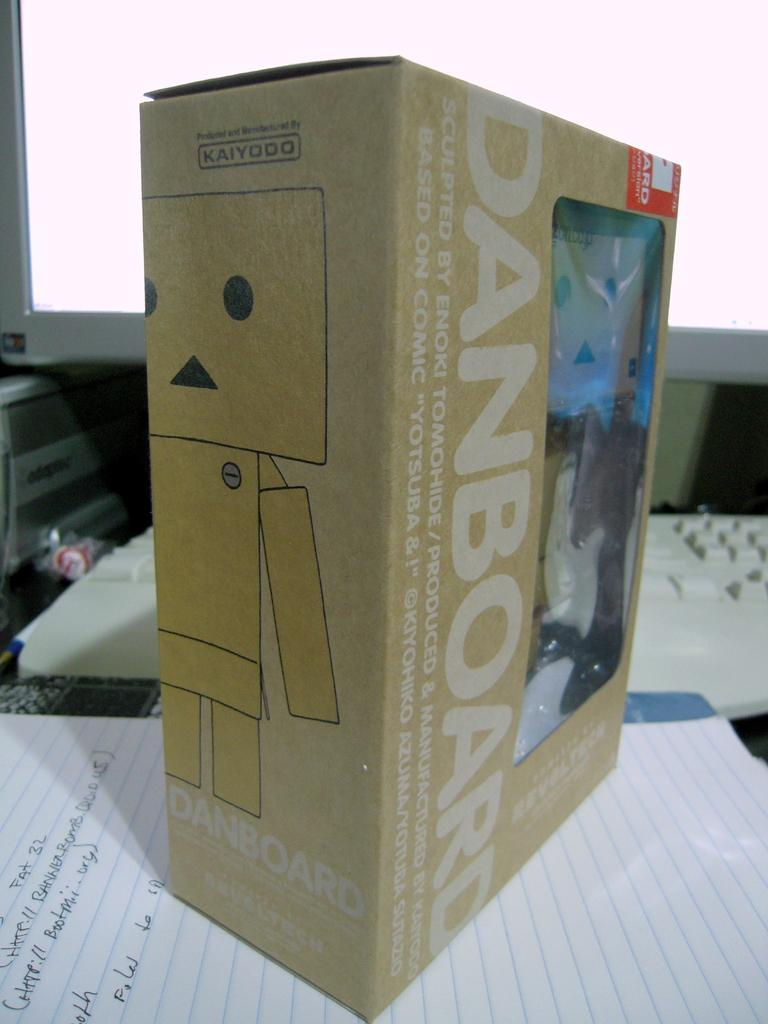What object is present in the image that can hold items? There is a box in the image that can hold items. What type of reading material is visible in the image? There is a book in the image. What is the written content on in the image? There is a paper with text in the image. What electronic devices are present in the background of the image? There is a monitor and a keyboard in the background of the image. What type of oil is being used to lubricate the base of the humor in the image? There is no oil, base, or humor present in the image. 